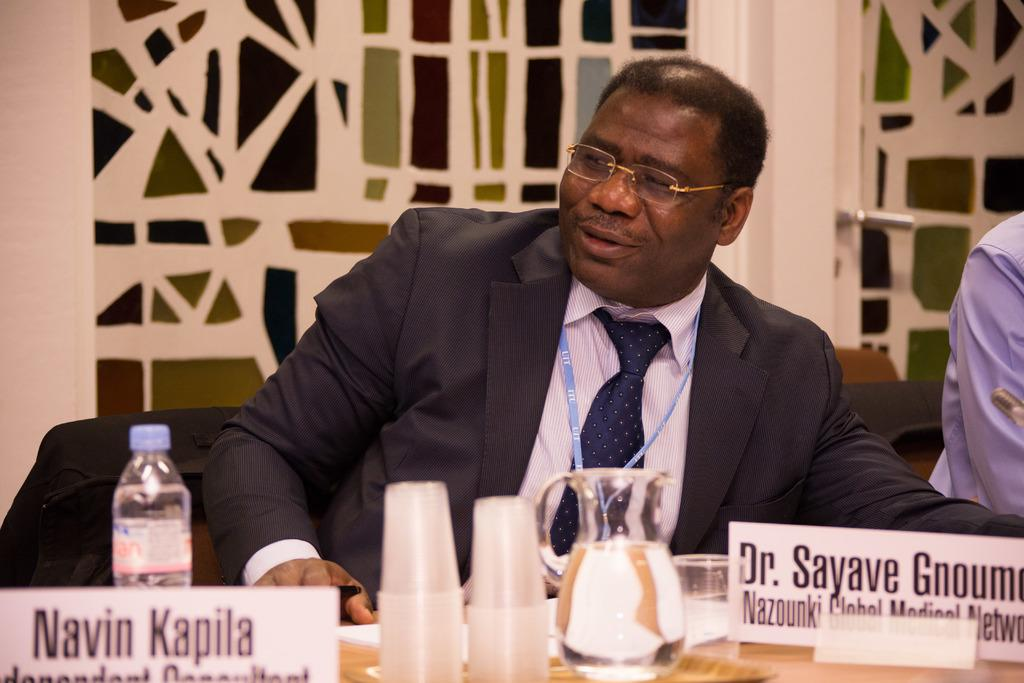What is the man in the image doing? The man is sitting in a chair. What type of clothing is the man wearing? The man is wearing a coat, a tie, and a shirt. What object is in front of the man? There is a water jug in front of the man. What type of dirt can be seen on the man's shoes in the image? There is no dirt visible on the man's shoes in the image. Where did the man go on vacation before the image was taken? There is no information about the man's vacation in the image. Is there a yak present in the image? No, there is no yak present in the image. 